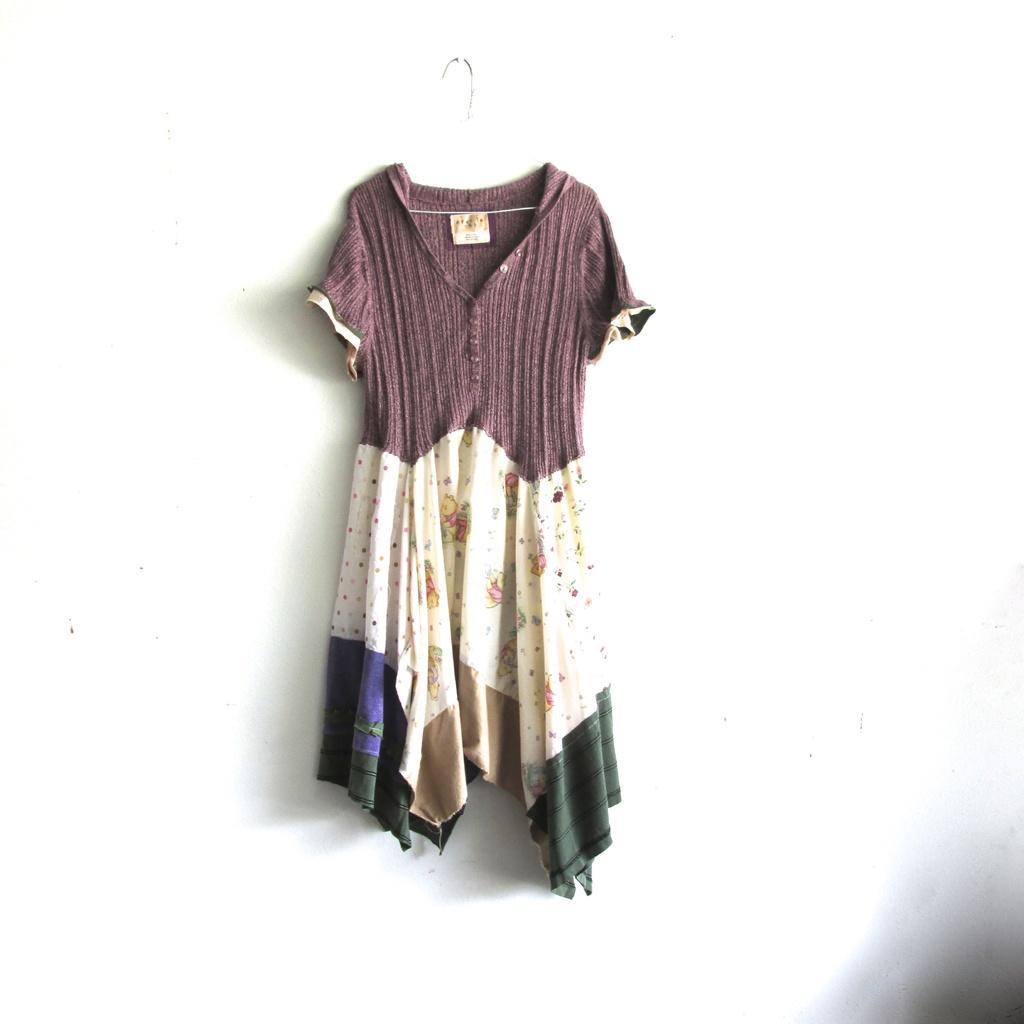Describe this image in one or two sentences. In this picture there is a cloth hanging which is in the center. 